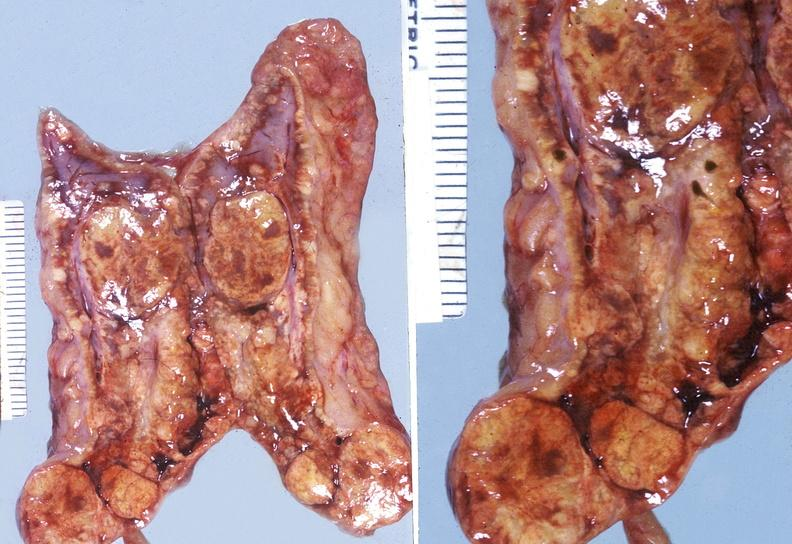what is present?
Answer the question using a single word or phrase. Endocrine 